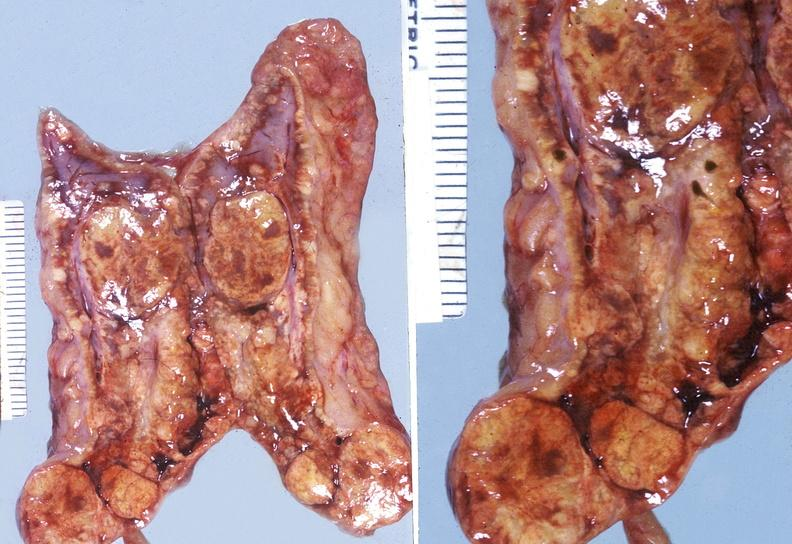what is present?
Answer the question using a single word or phrase. Endocrine 